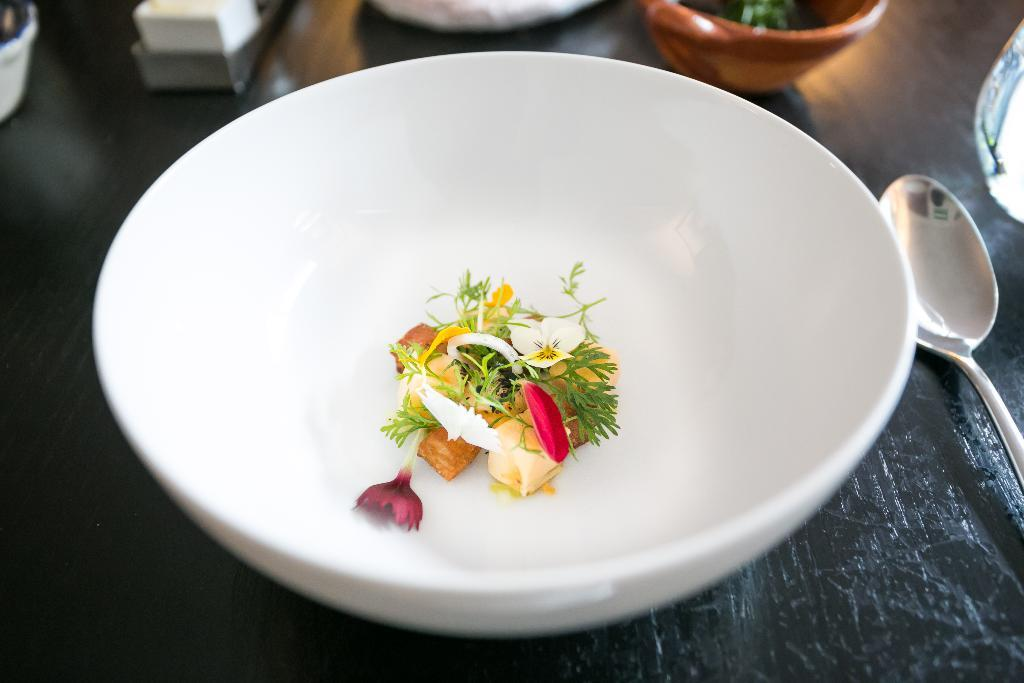What is the main subject in the center of the image? There are flowers in a bowl in the center of the image. What type of furniture is present in the image? There is a table in the image. What utensil can be seen on the table? There is a spoon on the table. How many bowls are visible on the table? There are bowls on the table. What other objects can be seen on the table? There are other objects on the table. How many cattle are grazing on the table in the image? There are no cattle present in the image; the table contains flowers in a bowl, a spoon, and other objects. 